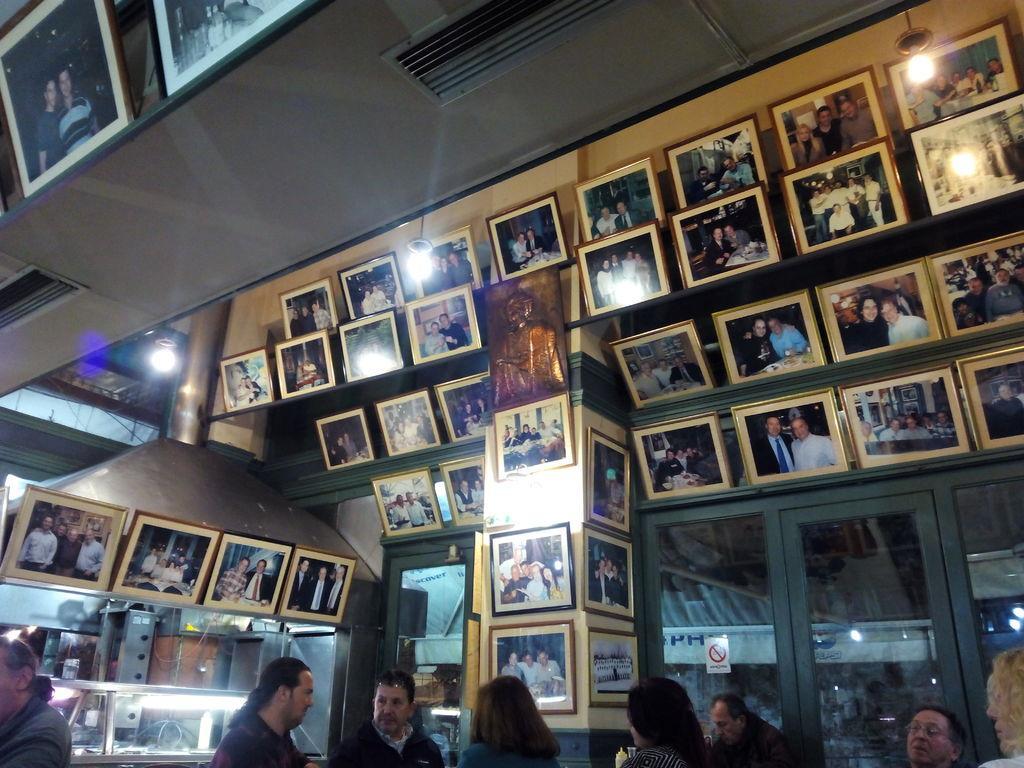How would you summarize this image in a sentence or two? In this picture there are people and we can see frames, lights, poster on a glass and objects. 